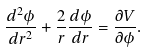Convert formula to latex. <formula><loc_0><loc_0><loc_500><loc_500>\frac { d ^ { 2 } \phi } { d r ^ { 2 } } + \frac { 2 } { r } \frac { d \phi } { d r } = \frac { \partial V } { \partial \phi } .</formula> 